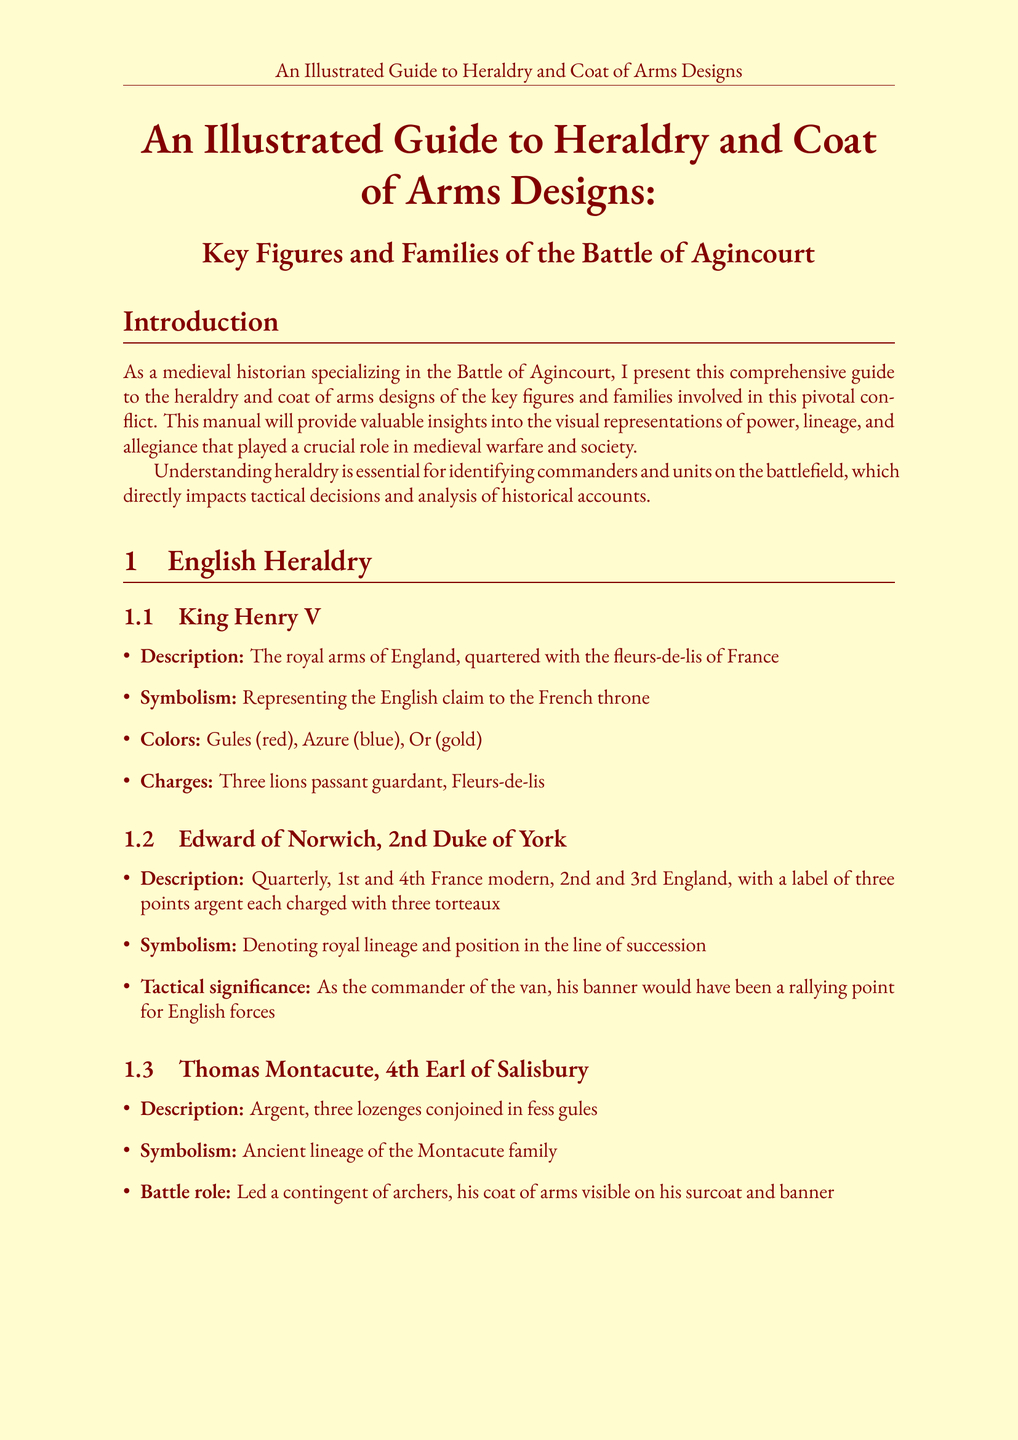What is the title of the document? The title is stated at the beginning of the document as "An Illustrated Guide to Heraldry and Coat of Arms Designs: Key Figures and Families of the Battle of Agincourt."
Answer: An Illustrated Guide to Heraldry and Coat of Arms Designs: Key Figures and Families of the Battle of Agincourt Who is the author of the document? The introduction identifies the author as a medieval historian specializing in the Battle of Agincourt.
Answer: A medieval historian What colors are used in King Henry V's coat of arms? The document lists the colors used in King Henry V's coat of arms.
Answer: Gules (red), Azure (blue), Or (gold) What heraldic charge is associated with Edward of Norwich? The document notes the specific charges associated with Edward of Norwich's coat of arms.
Answer: A label of three points argent each charged with three torteaux What is the tactical significance of Charles d'Albret's banner? The document mentions the tactical importance of Charles d'Albret's position and banner.
Answer: Guiding French maneuvers How did the Erpingham family change their heraldry after Agincourt? The document specifies the change made by the Erpingham family in their heraldry.
Answer: Added a small shield bearing the arms of France What was a key reason for the increased use of fleurs-de-lis by the House of Valois? The document explains the reason for the House of Valois's alteration in heraldic imagery post-battle.
Answer: To reinforce French royal authority What does the prominence of blue in French heraldry signify? The section on colors indicates the significance of blue (azure) in French heraldry.
Answer: Quick identification of allies and enemies What role did Thomas Montacute play in the battle? The document describes the battle role of Thomas Montacute, illustrating his involvement.
Answer: Led a contingent of archers 